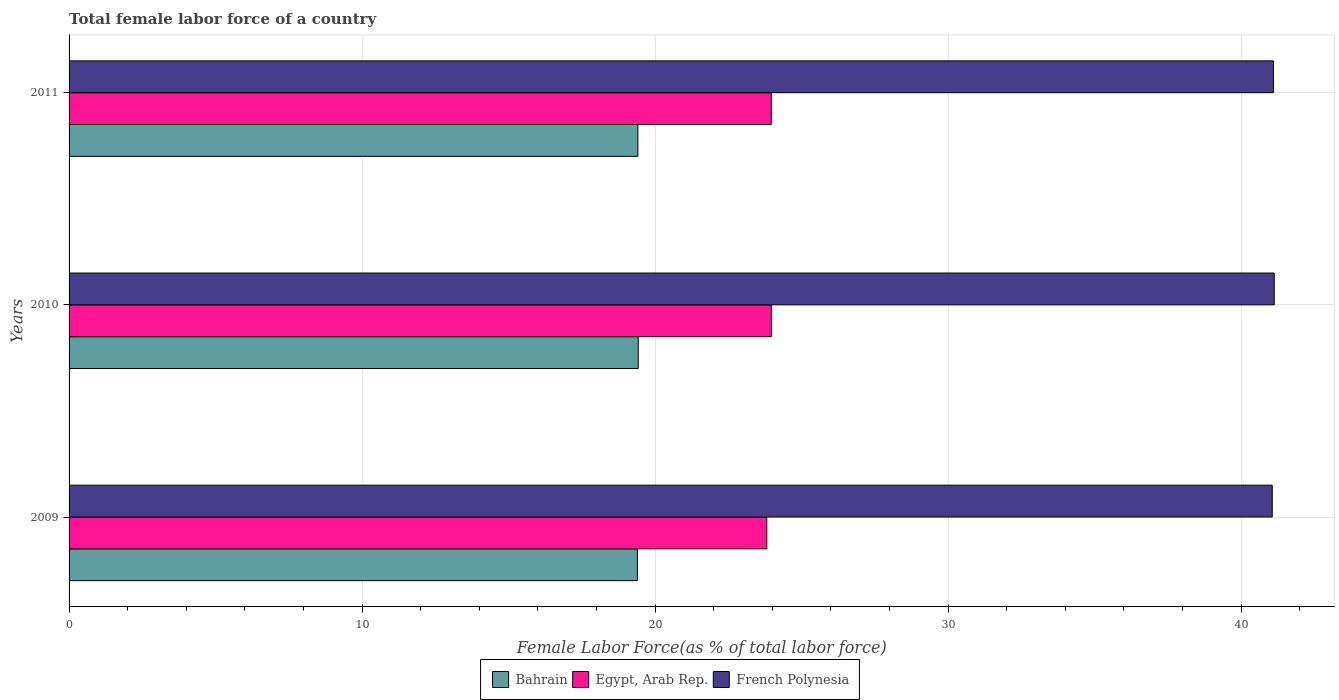How many groups of bars are there?
Offer a very short reply. 3. How many bars are there on the 1st tick from the bottom?
Your response must be concise. 3. In how many cases, is the number of bars for a given year not equal to the number of legend labels?
Your answer should be compact. 0. What is the percentage of female labor force in Bahrain in 2010?
Ensure brevity in your answer.  19.42. Across all years, what is the maximum percentage of female labor force in Egypt, Arab Rep.?
Your response must be concise. 23.97. Across all years, what is the minimum percentage of female labor force in Egypt, Arab Rep.?
Offer a terse response. 23.81. In which year was the percentage of female labor force in Bahrain maximum?
Keep it short and to the point. 2010. What is the total percentage of female labor force in Bahrain in the graph?
Keep it short and to the point. 58.23. What is the difference between the percentage of female labor force in French Polynesia in 2009 and that in 2011?
Give a very brief answer. -0.04. What is the difference between the percentage of female labor force in French Polynesia in 2009 and the percentage of female labor force in Bahrain in 2011?
Your response must be concise. 21.65. What is the average percentage of female labor force in Bahrain per year?
Give a very brief answer. 19.41. In the year 2009, what is the difference between the percentage of female labor force in Egypt, Arab Rep. and percentage of female labor force in French Polynesia?
Your answer should be very brief. -17.25. In how many years, is the percentage of female labor force in French Polynesia greater than 26 %?
Ensure brevity in your answer.  3. What is the ratio of the percentage of female labor force in French Polynesia in 2009 to that in 2011?
Provide a succinct answer. 1. What is the difference between the highest and the second highest percentage of female labor force in Egypt, Arab Rep.?
Offer a terse response. 0. What is the difference between the highest and the lowest percentage of female labor force in French Polynesia?
Provide a short and direct response. 0.07. In how many years, is the percentage of female labor force in Bahrain greater than the average percentage of female labor force in Bahrain taken over all years?
Keep it short and to the point. 2. Is the sum of the percentage of female labor force in Egypt, Arab Rep. in 2009 and 2011 greater than the maximum percentage of female labor force in Bahrain across all years?
Your answer should be compact. Yes. What does the 1st bar from the top in 2010 represents?
Your response must be concise. French Polynesia. What does the 3rd bar from the bottom in 2010 represents?
Give a very brief answer. French Polynesia. Is it the case that in every year, the sum of the percentage of female labor force in French Polynesia and percentage of female labor force in Egypt, Arab Rep. is greater than the percentage of female labor force in Bahrain?
Your answer should be very brief. Yes. How many bars are there?
Your answer should be compact. 9. Are all the bars in the graph horizontal?
Your answer should be very brief. Yes. Does the graph contain any zero values?
Your answer should be very brief. No. Does the graph contain grids?
Provide a succinct answer. Yes. What is the title of the graph?
Make the answer very short. Total female labor force of a country. What is the label or title of the X-axis?
Give a very brief answer. Female Labor Force(as % of total labor force). What is the Female Labor Force(as % of total labor force) in Bahrain in 2009?
Make the answer very short. 19.4. What is the Female Labor Force(as % of total labor force) of Egypt, Arab Rep. in 2009?
Give a very brief answer. 23.81. What is the Female Labor Force(as % of total labor force) in French Polynesia in 2009?
Provide a succinct answer. 41.06. What is the Female Labor Force(as % of total labor force) in Bahrain in 2010?
Keep it short and to the point. 19.42. What is the Female Labor Force(as % of total labor force) of Egypt, Arab Rep. in 2010?
Your answer should be very brief. 23.97. What is the Female Labor Force(as % of total labor force) of French Polynesia in 2010?
Your answer should be compact. 41.13. What is the Female Labor Force(as % of total labor force) in Bahrain in 2011?
Provide a succinct answer. 19.41. What is the Female Labor Force(as % of total labor force) of Egypt, Arab Rep. in 2011?
Keep it short and to the point. 23.96. What is the Female Labor Force(as % of total labor force) in French Polynesia in 2011?
Ensure brevity in your answer.  41.1. Across all years, what is the maximum Female Labor Force(as % of total labor force) of Bahrain?
Ensure brevity in your answer.  19.42. Across all years, what is the maximum Female Labor Force(as % of total labor force) of Egypt, Arab Rep.?
Offer a terse response. 23.97. Across all years, what is the maximum Female Labor Force(as % of total labor force) of French Polynesia?
Your response must be concise. 41.13. Across all years, what is the minimum Female Labor Force(as % of total labor force) in Bahrain?
Give a very brief answer. 19.4. Across all years, what is the minimum Female Labor Force(as % of total labor force) of Egypt, Arab Rep.?
Offer a terse response. 23.81. Across all years, what is the minimum Female Labor Force(as % of total labor force) of French Polynesia?
Ensure brevity in your answer.  41.06. What is the total Female Labor Force(as % of total labor force) in Bahrain in the graph?
Give a very brief answer. 58.23. What is the total Female Labor Force(as % of total labor force) in Egypt, Arab Rep. in the graph?
Your answer should be compact. 71.74. What is the total Female Labor Force(as % of total labor force) of French Polynesia in the graph?
Your response must be concise. 123.3. What is the difference between the Female Labor Force(as % of total labor force) in Bahrain in 2009 and that in 2010?
Your response must be concise. -0.03. What is the difference between the Female Labor Force(as % of total labor force) of Egypt, Arab Rep. in 2009 and that in 2010?
Your response must be concise. -0.15. What is the difference between the Female Labor Force(as % of total labor force) of French Polynesia in 2009 and that in 2010?
Offer a terse response. -0.07. What is the difference between the Female Labor Force(as % of total labor force) of Bahrain in 2009 and that in 2011?
Your answer should be very brief. -0.02. What is the difference between the Female Labor Force(as % of total labor force) in Egypt, Arab Rep. in 2009 and that in 2011?
Keep it short and to the point. -0.15. What is the difference between the Female Labor Force(as % of total labor force) of French Polynesia in 2009 and that in 2011?
Your answer should be compact. -0.04. What is the difference between the Female Labor Force(as % of total labor force) of Bahrain in 2010 and that in 2011?
Your response must be concise. 0.01. What is the difference between the Female Labor Force(as % of total labor force) in Egypt, Arab Rep. in 2010 and that in 2011?
Provide a short and direct response. 0. What is the difference between the Female Labor Force(as % of total labor force) in French Polynesia in 2010 and that in 2011?
Offer a terse response. 0.03. What is the difference between the Female Labor Force(as % of total labor force) in Bahrain in 2009 and the Female Labor Force(as % of total labor force) in Egypt, Arab Rep. in 2010?
Make the answer very short. -4.57. What is the difference between the Female Labor Force(as % of total labor force) of Bahrain in 2009 and the Female Labor Force(as % of total labor force) of French Polynesia in 2010?
Give a very brief answer. -21.73. What is the difference between the Female Labor Force(as % of total labor force) of Egypt, Arab Rep. in 2009 and the Female Labor Force(as % of total labor force) of French Polynesia in 2010?
Ensure brevity in your answer.  -17.32. What is the difference between the Female Labor Force(as % of total labor force) of Bahrain in 2009 and the Female Labor Force(as % of total labor force) of Egypt, Arab Rep. in 2011?
Provide a short and direct response. -4.57. What is the difference between the Female Labor Force(as % of total labor force) of Bahrain in 2009 and the Female Labor Force(as % of total labor force) of French Polynesia in 2011?
Provide a short and direct response. -21.71. What is the difference between the Female Labor Force(as % of total labor force) of Egypt, Arab Rep. in 2009 and the Female Labor Force(as % of total labor force) of French Polynesia in 2011?
Keep it short and to the point. -17.29. What is the difference between the Female Labor Force(as % of total labor force) of Bahrain in 2010 and the Female Labor Force(as % of total labor force) of Egypt, Arab Rep. in 2011?
Ensure brevity in your answer.  -4.54. What is the difference between the Female Labor Force(as % of total labor force) in Bahrain in 2010 and the Female Labor Force(as % of total labor force) in French Polynesia in 2011?
Offer a very short reply. -21.68. What is the difference between the Female Labor Force(as % of total labor force) in Egypt, Arab Rep. in 2010 and the Female Labor Force(as % of total labor force) in French Polynesia in 2011?
Provide a succinct answer. -17.13. What is the average Female Labor Force(as % of total labor force) in Bahrain per year?
Keep it short and to the point. 19.41. What is the average Female Labor Force(as % of total labor force) of Egypt, Arab Rep. per year?
Provide a short and direct response. 23.91. What is the average Female Labor Force(as % of total labor force) of French Polynesia per year?
Ensure brevity in your answer.  41.1. In the year 2009, what is the difference between the Female Labor Force(as % of total labor force) in Bahrain and Female Labor Force(as % of total labor force) in Egypt, Arab Rep.?
Offer a very short reply. -4.42. In the year 2009, what is the difference between the Female Labor Force(as % of total labor force) in Bahrain and Female Labor Force(as % of total labor force) in French Polynesia?
Your answer should be compact. -21.67. In the year 2009, what is the difference between the Female Labor Force(as % of total labor force) of Egypt, Arab Rep. and Female Labor Force(as % of total labor force) of French Polynesia?
Offer a terse response. -17.25. In the year 2010, what is the difference between the Female Labor Force(as % of total labor force) of Bahrain and Female Labor Force(as % of total labor force) of Egypt, Arab Rep.?
Provide a succinct answer. -4.54. In the year 2010, what is the difference between the Female Labor Force(as % of total labor force) of Bahrain and Female Labor Force(as % of total labor force) of French Polynesia?
Give a very brief answer. -21.71. In the year 2010, what is the difference between the Female Labor Force(as % of total labor force) in Egypt, Arab Rep. and Female Labor Force(as % of total labor force) in French Polynesia?
Give a very brief answer. -17.16. In the year 2011, what is the difference between the Female Labor Force(as % of total labor force) of Bahrain and Female Labor Force(as % of total labor force) of Egypt, Arab Rep.?
Give a very brief answer. -4.55. In the year 2011, what is the difference between the Female Labor Force(as % of total labor force) in Bahrain and Female Labor Force(as % of total labor force) in French Polynesia?
Ensure brevity in your answer.  -21.69. In the year 2011, what is the difference between the Female Labor Force(as % of total labor force) of Egypt, Arab Rep. and Female Labor Force(as % of total labor force) of French Polynesia?
Offer a terse response. -17.14. What is the ratio of the Female Labor Force(as % of total labor force) in Bahrain in 2009 to that in 2010?
Offer a terse response. 1. What is the ratio of the Female Labor Force(as % of total labor force) in French Polynesia in 2009 to that in 2010?
Offer a terse response. 1. What is the ratio of the Female Labor Force(as % of total labor force) in Bahrain in 2009 to that in 2011?
Offer a terse response. 1. What is the ratio of the Female Labor Force(as % of total labor force) in French Polynesia in 2009 to that in 2011?
Offer a very short reply. 1. What is the ratio of the Female Labor Force(as % of total labor force) of Bahrain in 2010 to that in 2011?
Your answer should be compact. 1. What is the difference between the highest and the second highest Female Labor Force(as % of total labor force) in Bahrain?
Make the answer very short. 0.01. What is the difference between the highest and the second highest Female Labor Force(as % of total labor force) in Egypt, Arab Rep.?
Your answer should be compact. 0. What is the difference between the highest and the second highest Female Labor Force(as % of total labor force) of French Polynesia?
Provide a short and direct response. 0.03. What is the difference between the highest and the lowest Female Labor Force(as % of total labor force) in Bahrain?
Your answer should be very brief. 0.03. What is the difference between the highest and the lowest Female Labor Force(as % of total labor force) in Egypt, Arab Rep.?
Keep it short and to the point. 0.15. What is the difference between the highest and the lowest Female Labor Force(as % of total labor force) of French Polynesia?
Keep it short and to the point. 0.07. 